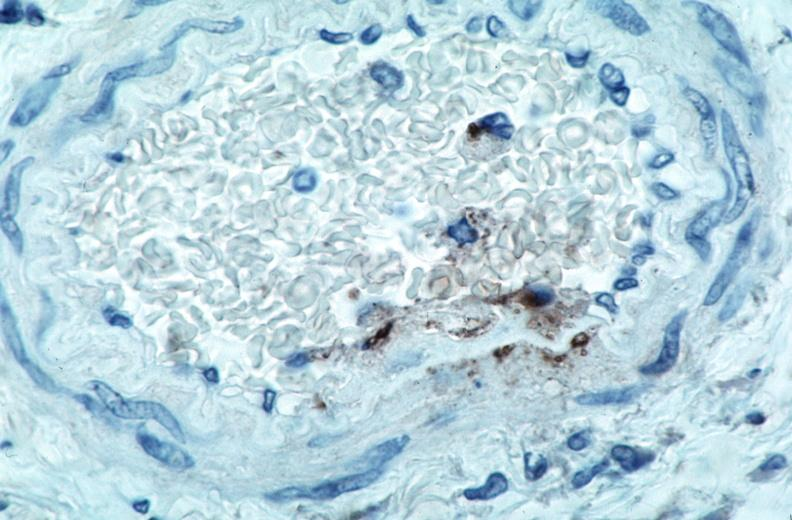where is this from?
Answer the question using a single word or phrase. Vasculature 